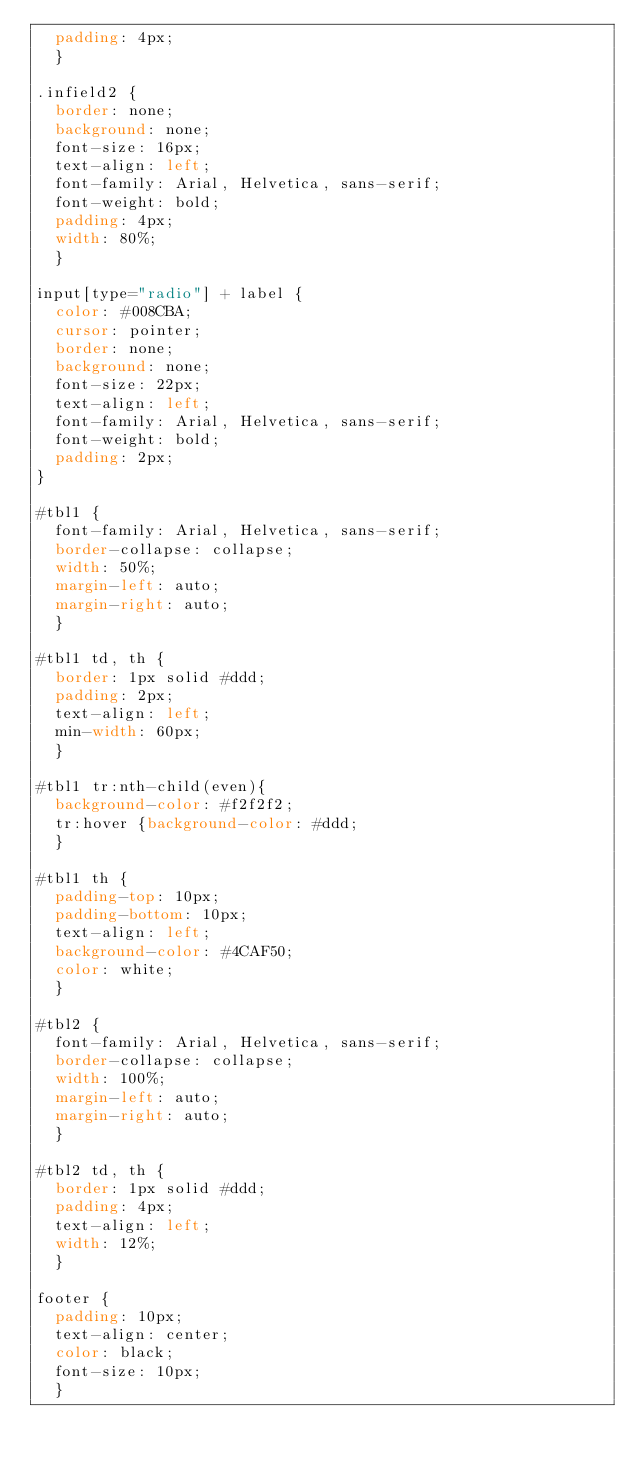Convert code to text. <code><loc_0><loc_0><loc_500><loc_500><_CSS_>  padding: 4px;
  }

.infield2 {
  border: none;
  background: none;
  font-size: 16px;
  text-align: left;
  font-family: Arial, Helvetica, sans-serif;
  font-weight: bold;
  padding: 4px;
  width: 80%;
  }

input[type="radio"] + label {
  color: #008CBA;
  cursor: pointer;
  border: none;
  background: none;
  font-size: 22px;
  text-align: left;
  font-family: Arial, Helvetica, sans-serif;
  font-weight: bold;
  padding: 2px;
}

#tbl1 {
  font-family: Arial, Helvetica, sans-serif;
  border-collapse: collapse;
  width: 50%;
  margin-left: auto;
  margin-right: auto;
  }

#tbl1 td, th {
  border: 1px solid #ddd;
  padding: 2px;
  text-align: left;
  min-width: 60px;
  }

#tbl1 tr:nth-child(even){
  background-color: #f2f2f2;
  tr:hover {background-color: #ddd;
  }

#tbl1 th {
  padding-top: 10px;
  padding-bottom: 10px;
  text-align: left;
  background-color: #4CAF50;
  color: white;
  }

#tbl2 {
  font-family: Arial, Helvetica, sans-serif;
  border-collapse: collapse;
  width: 100%;
  margin-left: auto;
  margin-right: auto;
  }

#tbl2 td, th {
  border: 1px solid #ddd;
  padding: 4px;
  text-align: left;
  width: 12%;
  }

footer {
  padding: 10px;
  text-align: center;
  color: black;
  font-size: 10px;
  }
</code> 